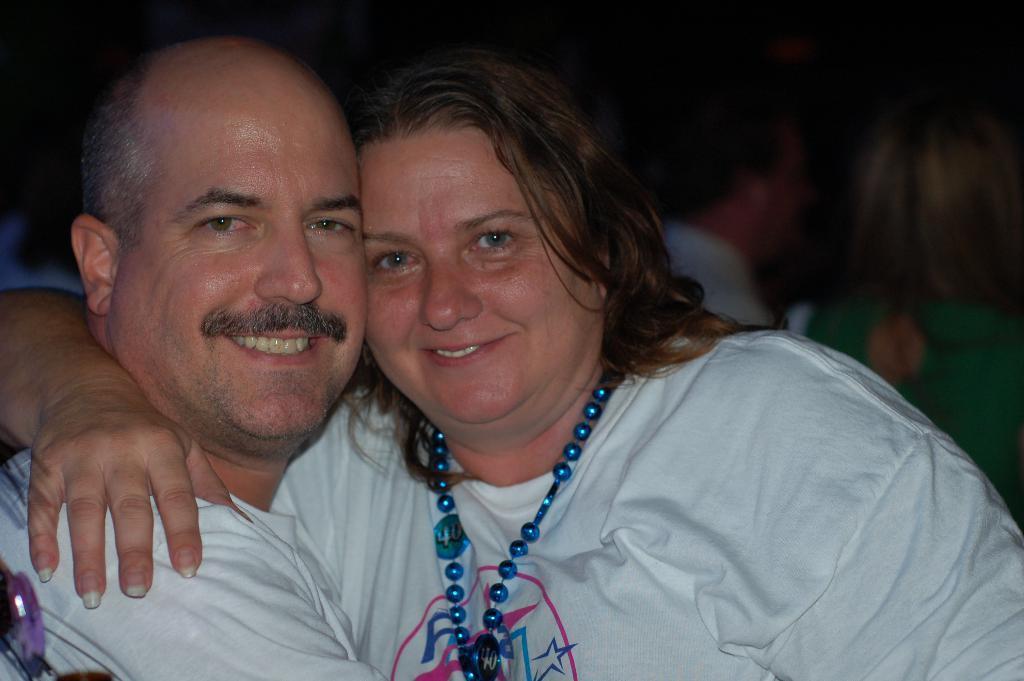In one or two sentences, can you explain what this image depicts? In this image in front there are two persons wearing a smile on their faces. Behind them there are few other people. 